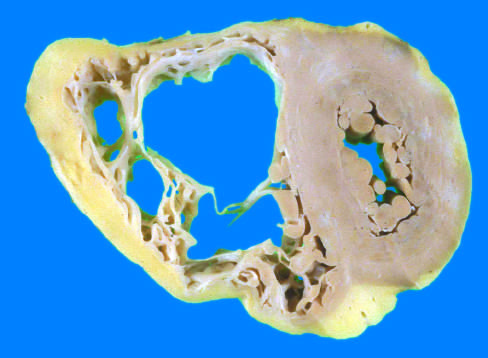what is markedly dilated with focal, almost transmural replacement of the free wall by adipose tissue and fibrosis?
Answer the question using a single word or phrase. The right ventricle 